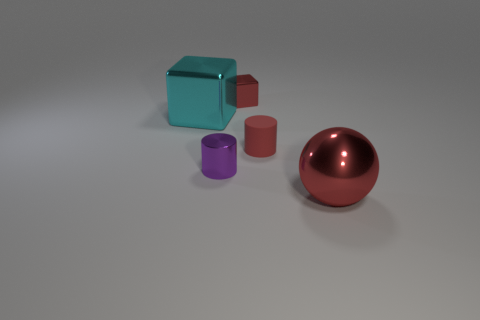Add 1 small blue metal cylinders. How many objects exist? 6 Subtract all cylinders. How many objects are left? 3 Subtract all large red shiny objects. Subtract all big red shiny spheres. How many objects are left? 3 Add 3 tiny blocks. How many tiny blocks are left? 4 Add 3 big brown metal spheres. How many big brown metal spheres exist? 3 Subtract 0 gray cylinders. How many objects are left? 5 